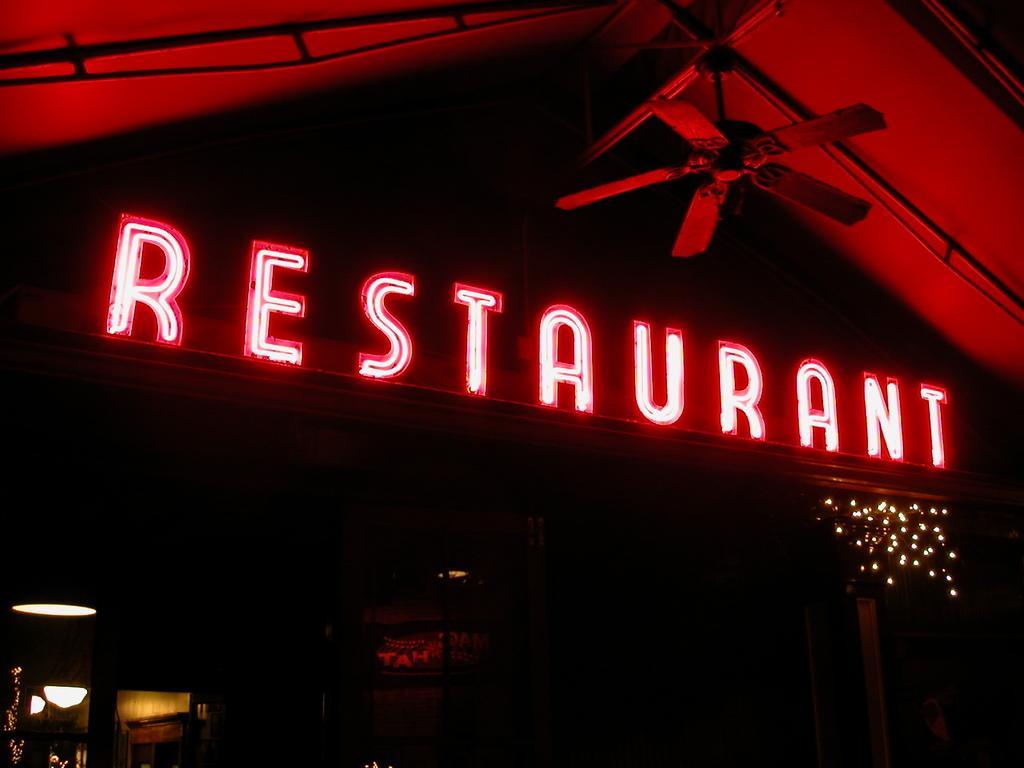In one or two sentences, can you explain what this image depicts? In this image we can see a store, name board and a ceiling fan. 